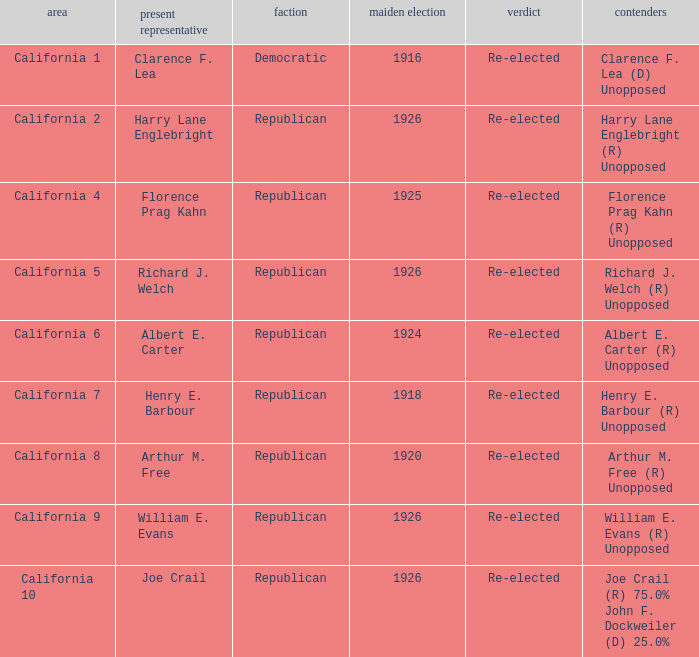What's the districtwith party being democratic California 1. Can you give me this table as a dict? {'header': ['area', 'present representative', 'faction', 'maiden election', 'verdict', 'contenders'], 'rows': [['California 1', 'Clarence F. Lea', 'Democratic', '1916', 'Re-elected', 'Clarence F. Lea (D) Unopposed'], ['California 2', 'Harry Lane Englebright', 'Republican', '1926', 'Re-elected', 'Harry Lane Englebright (R) Unopposed'], ['California 4', 'Florence Prag Kahn', 'Republican', '1925', 'Re-elected', 'Florence Prag Kahn (R) Unopposed'], ['California 5', 'Richard J. Welch', 'Republican', '1926', 'Re-elected', 'Richard J. Welch (R) Unopposed'], ['California 6', 'Albert E. Carter', 'Republican', '1924', 'Re-elected', 'Albert E. Carter (R) Unopposed'], ['California 7', 'Henry E. Barbour', 'Republican', '1918', 'Re-elected', 'Henry E. Barbour (R) Unopposed'], ['California 8', 'Arthur M. Free', 'Republican', '1920', 'Re-elected', 'Arthur M. Free (R) Unopposed'], ['California 9', 'William E. Evans', 'Republican', '1926', 'Re-elected', 'William E. Evans (R) Unopposed'], ['California 10', 'Joe Crail', 'Republican', '1926', 'Re-elected', 'Joe Crail (R) 75.0% John F. Dockweiler (D) 25.0%']]} 